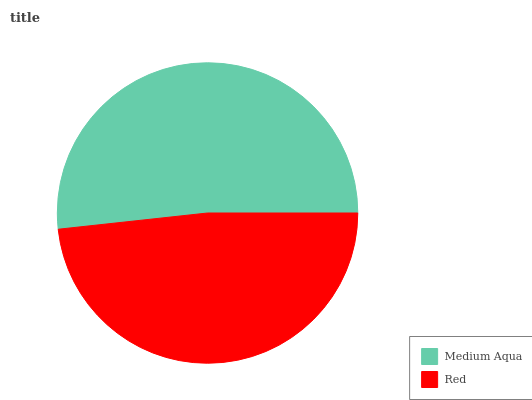Is Red the minimum?
Answer yes or no. Yes. Is Medium Aqua the maximum?
Answer yes or no. Yes. Is Red the maximum?
Answer yes or no. No. Is Medium Aqua greater than Red?
Answer yes or no. Yes. Is Red less than Medium Aqua?
Answer yes or no. Yes. Is Red greater than Medium Aqua?
Answer yes or no. No. Is Medium Aqua less than Red?
Answer yes or no. No. Is Medium Aqua the high median?
Answer yes or no. Yes. Is Red the low median?
Answer yes or no. Yes. Is Red the high median?
Answer yes or no. No. Is Medium Aqua the low median?
Answer yes or no. No. 